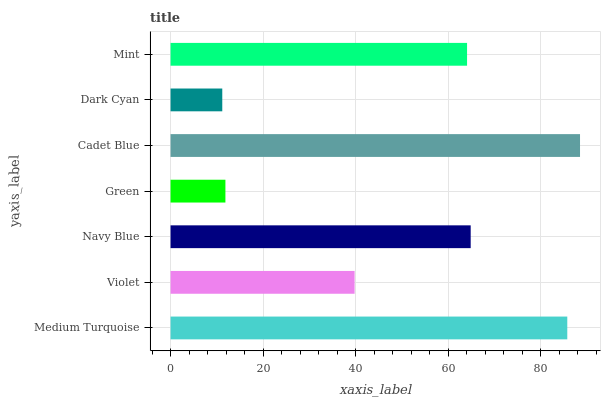Is Dark Cyan the minimum?
Answer yes or no. Yes. Is Cadet Blue the maximum?
Answer yes or no. Yes. Is Violet the minimum?
Answer yes or no. No. Is Violet the maximum?
Answer yes or no. No. Is Medium Turquoise greater than Violet?
Answer yes or no. Yes. Is Violet less than Medium Turquoise?
Answer yes or no. Yes. Is Violet greater than Medium Turquoise?
Answer yes or no. No. Is Medium Turquoise less than Violet?
Answer yes or no. No. Is Mint the high median?
Answer yes or no. Yes. Is Mint the low median?
Answer yes or no. Yes. Is Cadet Blue the high median?
Answer yes or no. No. Is Medium Turquoise the low median?
Answer yes or no. No. 